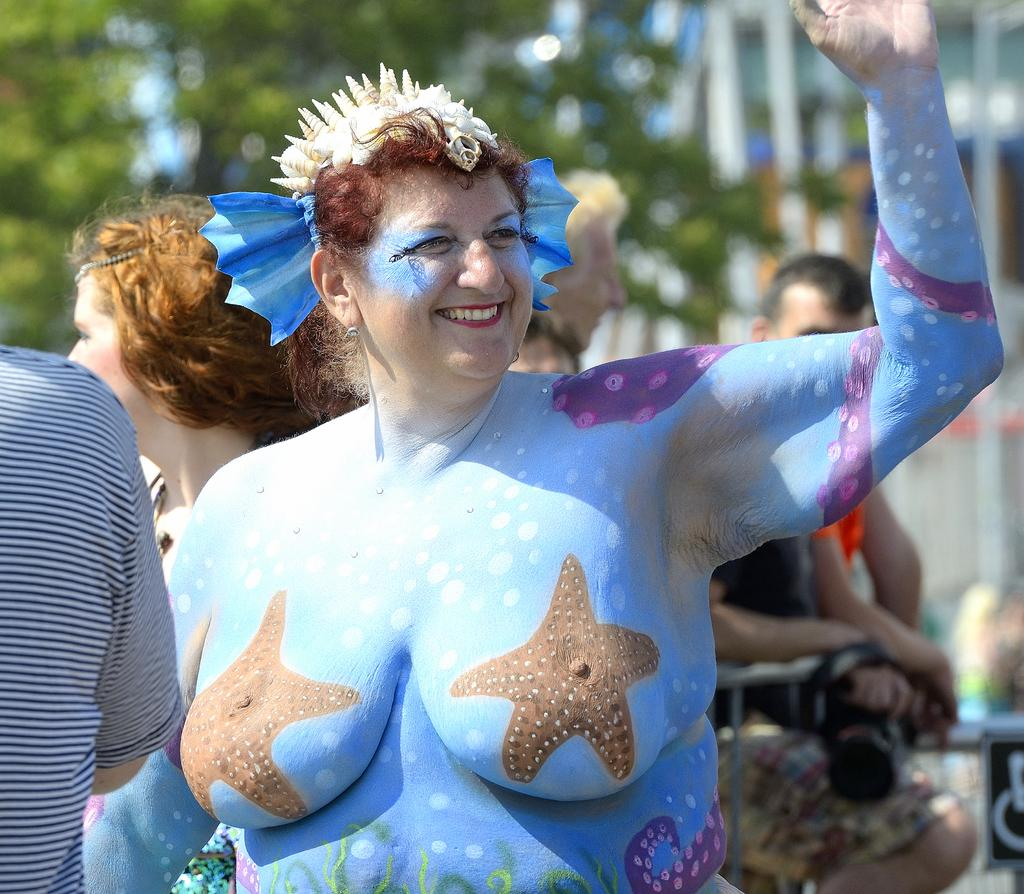Who is the main subject in the image? There is a woman in the image. What is unique about the woman's appearance? The woman has a painting on her body. Are there any other people in the image? Yes, there are people standing in the image. What can be seen in the background of the image? There is a tree visible in the background. How would you describe the background of the image? The background is blurred. What type of trouble is the woman experiencing in the image? There is no indication of trouble in the image; the woman has a painting on her body and is surrounded by other people. How does the woman twist her body in the image? There is no indication of the woman twisting her body in the image; she is standing still with a painting on her body. 